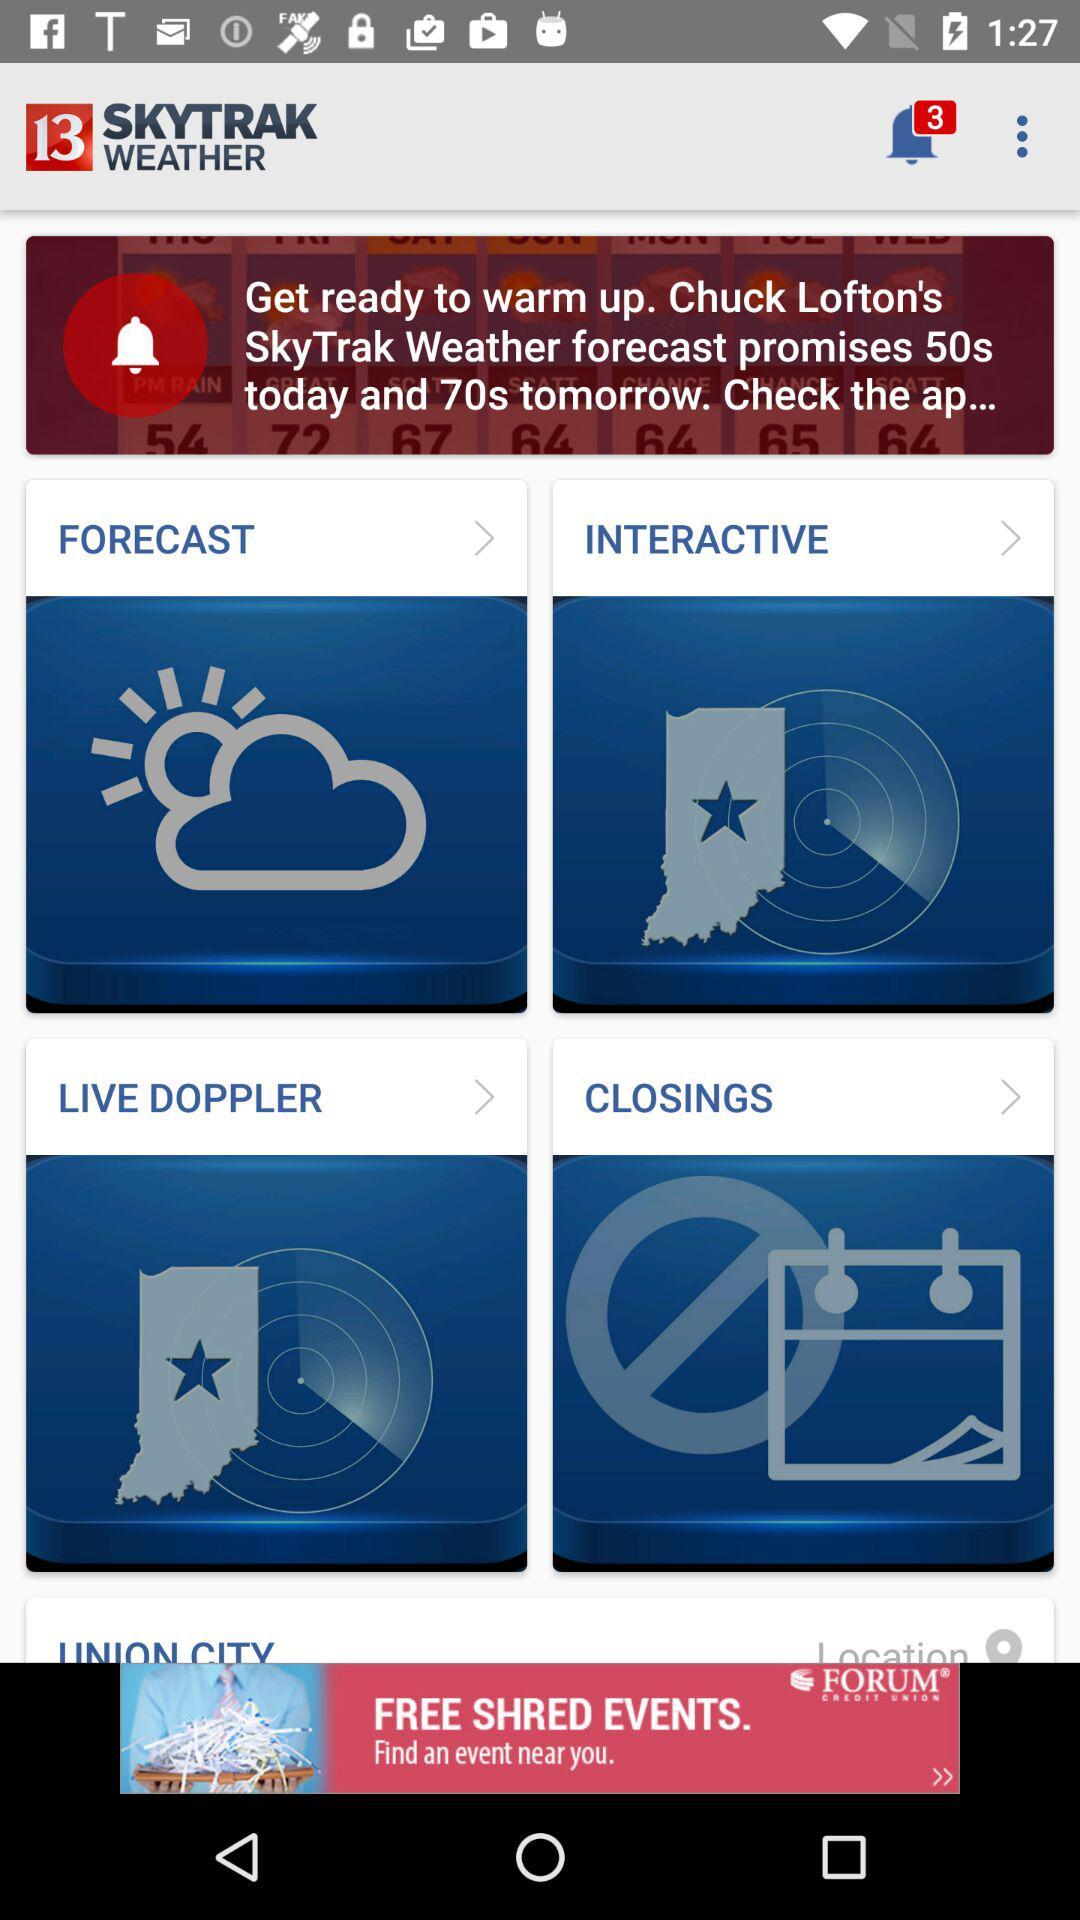What is the name of the application? The name of the application is "SKYTRAK WEATHER". 